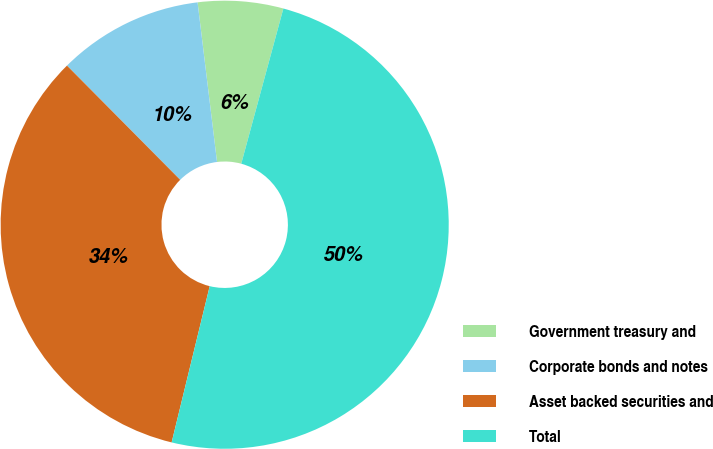Convert chart to OTSL. <chart><loc_0><loc_0><loc_500><loc_500><pie_chart><fcel>Government treasury and<fcel>Corporate bonds and notes<fcel>Asset backed securities and<fcel>Total<nl><fcel>6.15%<fcel>10.5%<fcel>33.77%<fcel>49.59%<nl></chart> 